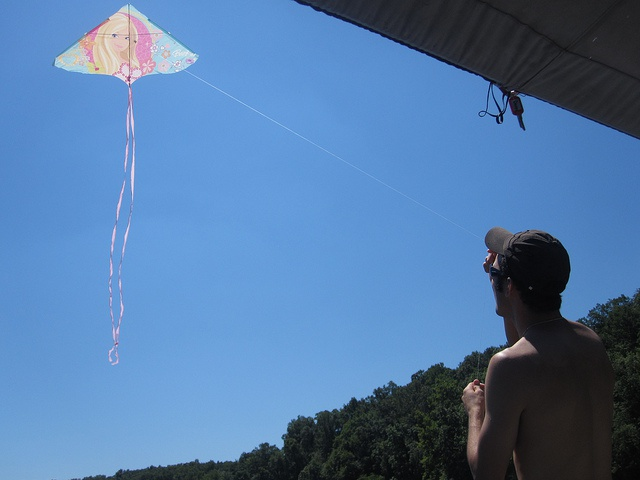Describe the objects in this image and their specific colors. I can see people in gray and black tones and kite in gray, lightgray, lightblue, lightpink, and tan tones in this image. 